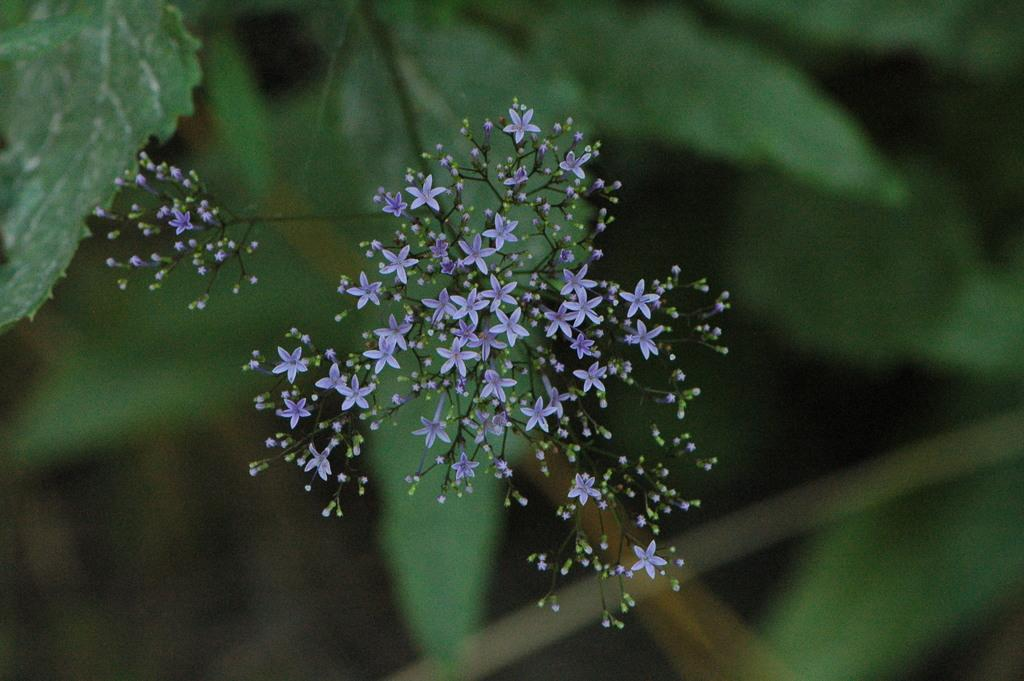What is the main subject of the image? The main subject of the image is flowers. Where are the flowers located in the image? The flowers are in the center of the image. What else can be seen in the background of the image? There are leaves in the background of the image. What type of prose can be seen in the image? There is no prose present in the image; it features flowers and leaves. What direction is the zephyr blowing in the image? There is no mention of a zephyr or any wind in the image; it only shows flowers and leaves. 